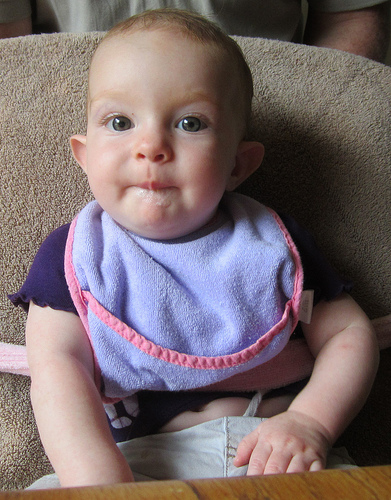<image>
Can you confirm if the baby is next to the chair? No. The baby is not positioned next to the chair. They are located in different areas of the scene. Is the baby under the chair? No. The baby is not positioned under the chair. The vertical relationship between these objects is different. Is the baby in front of the table? Yes. The baby is positioned in front of the table, appearing closer to the camera viewpoint. Where is the baby in relation to the table? Is it above the table? No. The baby is not positioned above the table. The vertical arrangement shows a different relationship. 